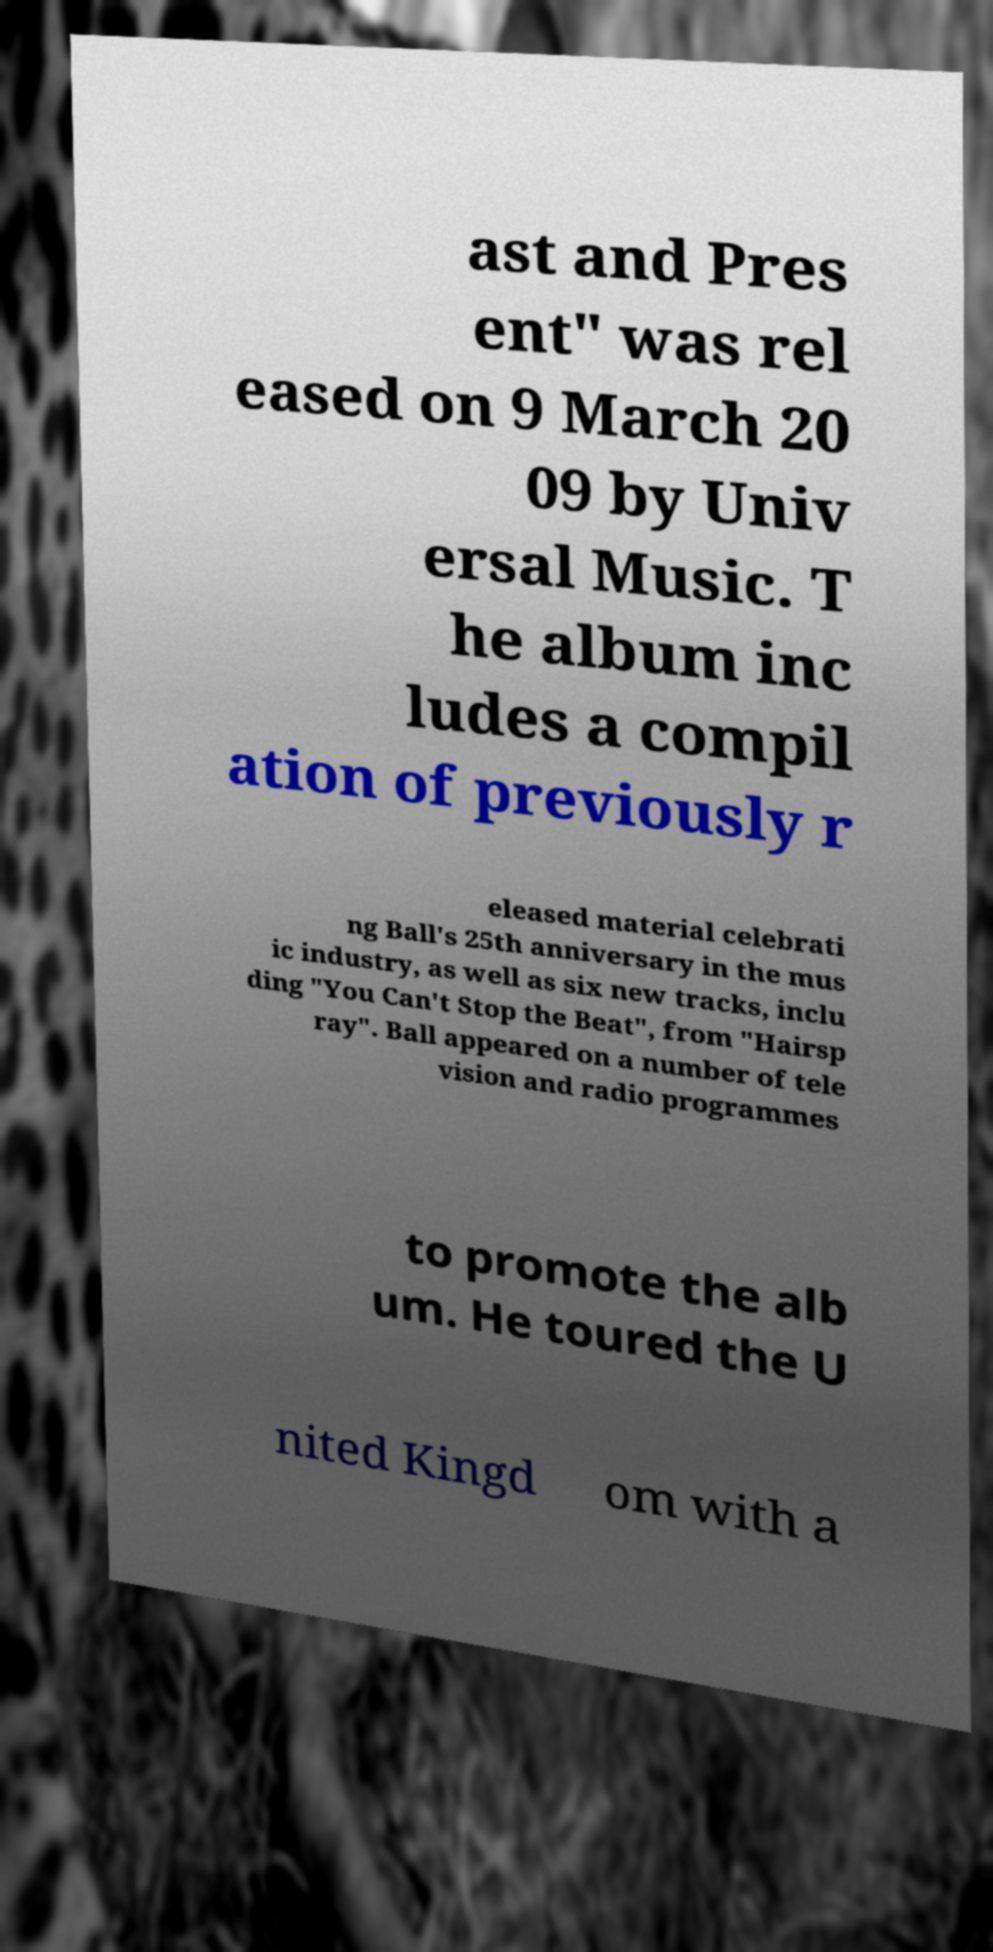Please identify and transcribe the text found in this image. ast and Pres ent" was rel eased on 9 March 20 09 by Univ ersal Music. T he album inc ludes a compil ation of previously r eleased material celebrati ng Ball's 25th anniversary in the mus ic industry, as well as six new tracks, inclu ding "You Can't Stop the Beat", from "Hairsp ray". Ball appeared on a number of tele vision and radio programmes to promote the alb um. He toured the U nited Kingd om with a 